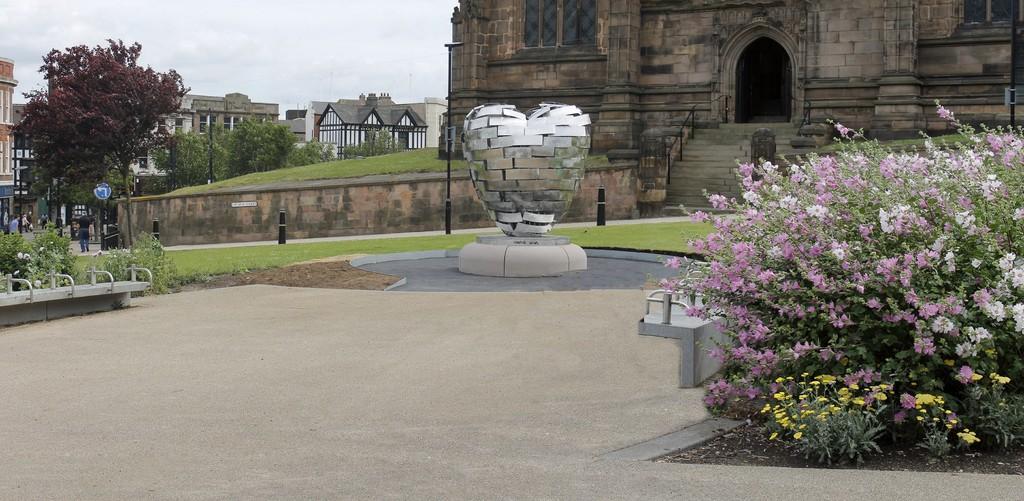Please provide a concise description of this image. In this image I can see flowers, plants, few poles, a blue colour sign board, number of buildings, stairs, few trees and the sky in background. I can also see few people are standing over there. 